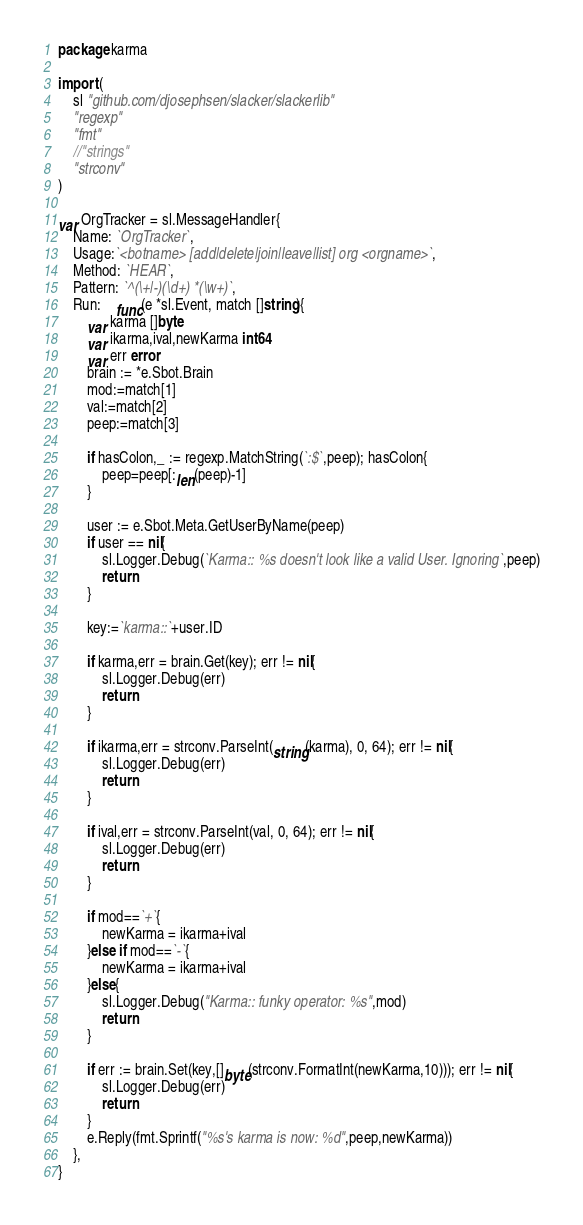Convert code to text. <code><loc_0><loc_0><loc_500><loc_500><_Go_>package karma

import (
	sl "github.com/djosephsen/slacker/slackerlib"
	"regexp"
	"fmt"
	//"strings"
	"strconv"
)

var OrgTracker = sl.MessageHandler{
	Name: `OrgTracker`,
	Usage:`<botname> [add|delete|join|leave|list] org <orgname>`,
	Method: `HEAR`,
	Pattern: `^(\+|-)(\d+) *(\w+)`,
	Run:	func(e *sl.Event, match []string){
		var karma []byte
		var ikarma,ival,newKarma int64
		var err error
		brain := *e.Sbot.Brain
		mod:=match[1]
		val:=match[2]
		peep:=match[3]

		if hasColon,_ := regexp.MatchString(`:$`,peep); hasColon{
			peep=peep[:len(peep)-1]
		}

		user := e.Sbot.Meta.GetUserByName(peep)
		if user == nil{
			sl.Logger.Debug(`Karma:: %s doesn't look like a valid User. Ignoring`,peep)
			return
		}

		key:=`karma::`+user.ID

		if karma,err = brain.Get(key); err != nil{
			sl.Logger.Debug(err)
			return
		}

		if ikarma,err = strconv.ParseInt(string(karma), 0, 64); err != nil{
			sl.Logger.Debug(err)
			return
		}

		if ival,err = strconv.ParseInt(val, 0, 64); err != nil{
			sl.Logger.Debug(err)
			return
		}

		if mod==`+`{
			newKarma = ikarma+ival
		}else if mod==`-`{
			newKarma = ikarma+ival
		}else{
			sl.Logger.Debug("Karma:: funky operator: %s",mod)
			return
		}

		if err := brain.Set(key,[]byte(strconv.FormatInt(newKarma,10))); err != nil{
			sl.Logger.Debug(err)
			return
		}
		e.Reply(fmt.Sprintf("%s's karma is now: %d",peep,newKarma))
	},
}
</code> 